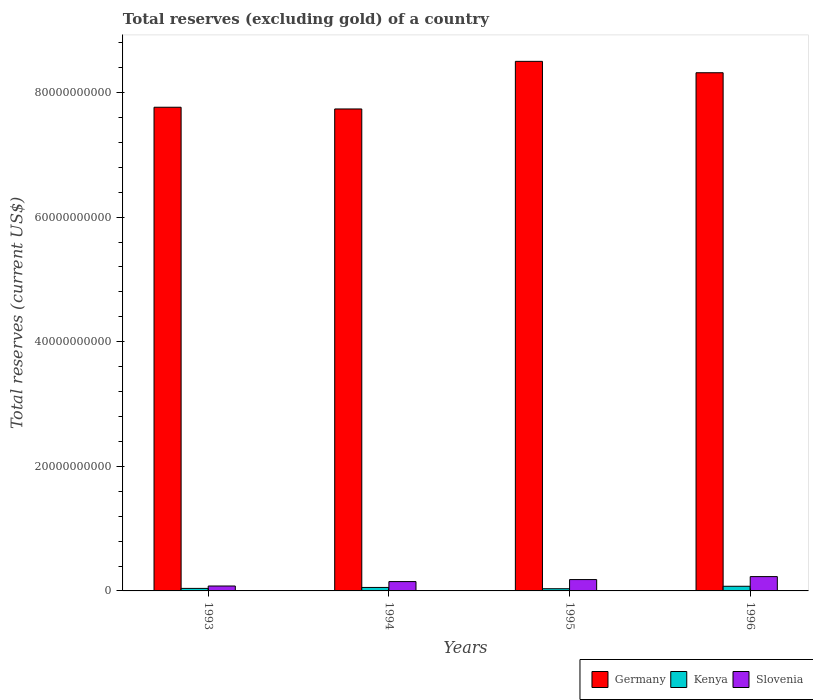How many groups of bars are there?
Your response must be concise. 4. Are the number of bars on each tick of the X-axis equal?
Offer a terse response. Yes. In how many cases, is the number of bars for a given year not equal to the number of legend labels?
Your response must be concise. 0. What is the total reserves (excluding gold) in Germany in 1995?
Provide a succinct answer. 8.50e+1. Across all years, what is the maximum total reserves (excluding gold) in Slovenia?
Your response must be concise. 2.30e+09. Across all years, what is the minimum total reserves (excluding gold) in Slovenia?
Your answer should be compact. 7.88e+08. What is the total total reserves (excluding gold) in Kenya in the graph?
Make the answer very short. 2.06e+09. What is the difference between the total reserves (excluding gold) in Kenya in 1994 and that in 1995?
Your response must be concise. 2.04e+08. What is the difference between the total reserves (excluding gold) in Kenya in 1993 and the total reserves (excluding gold) in Slovenia in 1995?
Provide a succinct answer. -1.42e+09. What is the average total reserves (excluding gold) in Germany per year?
Ensure brevity in your answer.  8.08e+1. In the year 1994, what is the difference between the total reserves (excluding gold) in Kenya and total reserves (excluding gold) in Germany?
Your answer should be very brief. -7.68e+1. In how many years, is the total reserves (excluding gold) in Kenya greater than 64000000000 US$?
Your answer should be compact. 0. What is the ratio of the total reserves (excluding gold) in Slovenia in 1993 to that in 1995?
Provide a short and direct response. 0.43. What is the difference between the highest and the second highest total reserves (excluding gold) in Germany?
Make the answer very short. 1.83e+09. What is the difference between the highest and the lowest total reserves (excluding gold) in Kenya?
Ensure brevity in your answer.  3.93e+08. In how many years, is the total reserves (excluding gold) in Kenya greater than the average total reserves (excluding gold) in Kenya taken over all years?
Your response must be concise. 2. Is the sum of the total reserves (excluding gold) in Slovenia in 1993 and 1994 greater than the maximum total reserves (excluding gold) in Kenya across all years?
Provide a short and direct response. Yes. What does the 1st bar from the left in 1994 represents?
Keep it short and to the point. Germany. Does the graph contain any zero values?
Offer a terse response. No. Does the graph contain grids?
Your answer should be very brief. No. What is the title of the graph?
Give a very brief answer. Total reserves (excluding gold) of a country. Does "Cyprus" appear as one of the legend labels in the graph?
Ensure brevity in your answer.  No. What is the label or title of the X-axis?
Make the answer very short. Years. What is the label or title of the Y-axis?
Your response must be concise. Total reserves (current US$). What is the Total reserves (current US$) in Germany in 1993?
Ensure brevity in your answer.  7.76e+1. What is the Total reserves (current US$) in Kenya in 1993?
Give a very brief answer. 4.06e+08. What is the Total reserves (current US$) of Slovenia in 1993?
Offer a very short reply. 7.88e+08. What is the Total reserves (current US$) of Germany in 1994?
Your answer should be compact. 7.74e+1. What is the Total reserves (current US$) of Kenya in 1994?
Give a very brief answer. 5.58e+08. What is the Total reserves (current US$) in Slovenia in 1994?
Keep it short and to the point. 1.50e+09. What is the Total reserves (current US$) in Germany in 1995?
Your answer should be compact. 8.50e+1. What is the Total reserves (current US$) of Kenya in 1995?
Make the answer very short. 3.53e+08. What is the Total reserves (current US$) of Slovenia in 1995?
Make the answer very short. 1.82e+09. What is the Total reserves (current US$) of Germany in 1996?
Keep it short and to the point. 8.32e+1. What is the Total reserves (current US$) in Kenya in 1996?
Your response must be concise. 7.46e+08. What is the Total reserves (current US$) of Slovenia in 1996?
Give a very brief answer. 2.30e+09. Across all years, what is the maximum Total reserves (current US$) in Germany?
Give a very brief answer. 8.50e+1. Across all years, what is the maximum Total reserves (current US$) of Kenya?
Your answer should be very brief. 7.46e+08. Across all years, what is the maximum Total reserves (current US$) of Slovenia?
Your answer should be very brief. 2.30e+09. Across all years, what is the minimum Total reserves (current US$) in Germany?
Your response must be concise. 7.74e+1. Across all years, what is the minimum Total reserves (current US$) in Kenya?
Give a very brief answer. 3.53e+08. Across all years, what is the minimum Total reserves (current US$) in Slovenia?
Your answer should be compact. 7.88e+08. What is the total Total reserves (current US$) of Germany in the graph?
Your answer should be very brief. 3.23e+11. What is the total Total reserves (current US$) of Kenya in the graph?
Your answer should be compact. 2.06e+09. What is the total Total reserves (current US$) of Slovenia in the graph?
Ensure brevity in your answer.  6.40e+09. What is the difference between the Total reserves (current US$) in Germany in 1993 and that in 1994?
Your answer should be very brief. 2.77e+08. What is the difference between the Total reserves (current US$) of Kenya in 1993 and that in 1994?
Provide a short and direct response. -1.52e+08. What is the difference between the Total reserves (current US$) in Slovenia in 1993 and that in 1994?
Make the answer very short. -7.11e+08. What is the difference between the Total reserves (current US$) in Germany in 1993 and that in 1995?
Ensure brevity in your answer.  -7.37e+09. What is the difference between the Total reserves (current US$) of Kenya in 1993 and that in 1995?
Make the answer very short. 5.22e+07. What is the difference between the Total reserves (current US$) in Slovenia in 1993 and that in 1995?
Your response must be concise. -1.03e+09. What is the difference between the Total reserves (current US$) of Germany in 1993 and that in 1996?
Offer a very short reply. -5.54e+09. What is the difference between the Total reserves (current US$) of Kenya in 1993 and that in 1996?
Offer a terse response. -3.41e+08. What is the difference between the Total reserves (current US$) of Slovenia in 1993 and that in 1996?
Offer a very short reply. -1.51e+09. What is the difference between the Total reserves (current US$) in Germany in 1994 and that in 1995?
Make the answer very short. -7.64e+09. What is the difference between the Total reserves (current US$) in Kenya in 1994 and that in 1995?
Your response must be concise. 2.04e+08. What is the difference between the Total reserves (current US$) in Slovenia in 1994 and that in 1995?
Your answer should be compact. -3.22e+08. What is the difference between the Total reserves (current US$) of Germany in 1994 and that in 1996?
Ensure brevity in your answer.  -5.81e+09. What is the difference between the Total reserves (current US$) in Kenya in 1994 and that in 1996?
Your answer should be compact. -1.89e+08. What is the difference between the Total reserves (current US$) in Slovenia in 1994 and that in 1996?
Give a very brief answer. -7.98e+08. What is the difference between the Total reserves (current US$) of Germany in 1995 and that in 1996?
Offer a terse response. 1.83e+09. What is the difference between the Total reserves (current US$) of Kenya in 1995 and that in 1996?
Make the answer very short. -3.93e+08. What is the difference between the Total reserves (current US$) in Slovenia in 1995 and that in 1996?
Your answer should be compact. -4.77e+08. What is the difference between the Total reserves (current US$) of Germany in 1993 and the Total reserves (current US$) of Kenya in 1994?
Give a very brief answer. 7.71e+1. What is the difference between the Total reserves (current US$) in Germany in 1993 and the Total reserves (current US$) in Slovenia in 1994?
Your response must be concise. 7.61e+1. What is the difference between the Total reserves (current US$) in Kenya in 1993 and the Total reserves (current US$) in Slovenia in 1994?
Your answer should be compact. -1.09e+09. What is the difference between the Total reserves (current US$) of Germany in 1993 and the Total reserves (current US$) of Kenya in 1995?
Your response must be concise. 7.73e+1. What is the difference between the Total reserves (current US$) of Germany in 1993 and the Total reserves (current US$) of Slovenia in 1995?
Ensure brevity in your answer.  7.58e+1. What is the difference between the Total reserves (current US$) of Kenya in 1993 and the Total reserves (current US$) of Slovenia in 1995?
Provide a succinct answer. -1.42e+09. What is the difference between the Total reserves (current US$) of Germany in 1993 and the Total reserves (current US$) of Kenya in 1996?
Offer a very short reply. 7.69e+1. What is the difference between the Total reserves (current US$) in Germany in 1993 and the Total reserves (current US$) in Slovenia in 1996?
Keep it short and to the point. 7.53e+1. What is the difference between the Total reserves (current US$) of Kenya in 1993 and the Total reserves (current US$) of Slovenia in 1996?
Your response must be concise. -1.89e+09. What is the difference between the Total reserves (current US$) of Germany in 1994 and the Total reserves (current US$) of Kenya in 1995?
Your response must be concise. 7.70e+1. What is the difference between the Total reserves (current US$) of Germany in 1994 and the Total reserves (current US$) of Slovenia in 1995?
Offer a terse response. 7.55e+1. What is the difference between the Total reserves (current US$) of Kenya in 1994 and the Total reserves (current US$) of Slovenia in 1995?
Give a very brief answer. -1.26e+09. What is the difference between the Total reserves (current US$) in Germany in 1994 and the Total reserves (current US$) in Kenya in 1996?
Ensure brevity in your answer.  7.66e+1. What is the difference between the Total reserves (current US$) in Germany in 1994 and the Total reserves (current US$) in Slovenia in 1996?
Give a very brief answer. 7.51e+1. What is the difference between the Total reserves (current US$) in Kenya in 1994 and the Total reserves (current US$) in Slovenia in 1996?
Your answer should be very brief. -1.74e+09. What is the difference between the Total reserves (current US$) of Germany in 1995 and the Total reserves (current US$) of Kenya in 1996?
Keep it short and to the point. 8.43e+1. What is the difference between the Total reserves (current US$) in Germany in 1995 and the Total reserves (current US$) in Slovenia in 1996?
Offer a very short reply. 8.27e+1. What is the difference between the Total reserves (current US$) in Kenya in 1995 and the Total reserves (current US$) in Slovenia in 1996?
Provide a succinct answer. -1.94e+09. What is the average Total reserves (current US$) of Germany per year?
Your response must be concise. 8.08e+1. What is the average Total reserves (current US$) in Kenya per year?
Your answer should be compact. 5.16e+08. What is the average Total reserves (current US$) of Slovenia per year?
Your answer should be compact. 1.60e+09. In the year 1993, what is the difference between the Total reserves (current US$) in Germany and Total reserves (current US$) in Kenya?
Provide a short and direct response. 7.72e+1. In the year 1993, what is the difference between the Total reserves (current US$) of Germany and Total reserves (current US$) of Slovenia?
Your answer should be compact. 7.69e+1. In the year 1993, what is the difference between the Total reserves (current US$) in Kenya and Total reserves (current US$) in Slovenia?
Your response must be concise. -3.82e+08. In the year 1994, what is the difference between the Total reserves (current US$) in Germany and Total reserves (current US$) in Kenya?
Your answer should be compact. 7.68e+1. In the year 1994, what is the difference between the Total reserves (current US$) of Germany and Total reserves (current US$) of Slovenia?
Keep it short and to the point. 7.59e+1. In the year 1994, what is the difference between the Total reserves (current US$) in Kenya and Total reserves (current US$) in Slovenia?
Provide a succinct answer. -9.41e+08. In the year 1995, what is the difference between the Total reserves (current US$) in Germany and Total reserves (current US$) in Kenya?
Ensure brevity in your answer.  8.47e+1. In the year 1995, what is the difference between the Total reserves (current US$) of Germany and Total reserves (current US$) of Slovenia?
Offer a very short reply. 8.32e+1. In the year 1995, what is the difference between the Total reserves (current US$) of Kenya and Total reserves (current US$) of Slovenia?
Your answer should be compact. -1.47e+09. In the year 1996, what is the difference between the Total reserves (current US$) in Germany and Total reserves (current US$) in Kenya?
Give a very brief answer. 8.24e+1. In the year 1996, what is the difference between the Total reserves (current US$) of Germany and Total reserves (current US$) of Slovenia?
Your answer should be compact. 8.09e+1. In the year 1996, what is the difference between the Total reserves (current US$) in Kenya and Total reserves (current US$) in Slovenia?
Your answer should be very brief. -1.55e+09. What is the ratio of the Total reserves (current US$) of Germany in 1993 to that in 1994?
Provide a succinct answer. 1. What is the ratio of the Total reserves (current US$) of Kenya in 1993 to that in 1994?
Offer a terse response. 0.73. What is the ratio of the Total reserves (current US$) in Slovenia in 1993 to that in 1994?
Your response must be concise. 0.53. What is the ratio of the Total reserves (current US$) of Germany in 1993 to that in 1995?
Make the answer very short. 0.91. What is the ratio of the Total reserves (current US$) of Kenya in 1993 to that in 1995?
Your answer should be very brief. 1.15. What is the ratio of the Total reserves (current US$) of Slovenia in 1993 to that in 1995?
Your answer should be compact. 0.43. What is the ratio of the Total reserves (current US$) of Germany in 1993 to that in 1996?
Provide a succinct answer. 0.93. What is the ratio of the Total reserves (current US$) in Kenya in 1993 to that in 1996?
Make the answer very short. 0.54. What is the ratio of the Total reserves (current US$) of Slovenia in 1993 to that in 1996?
Provide a short and direct response. 0.34. What is the ratio of the Total reserves (current US$) in Germany in 1994 to that in 1995?
Offer a terse response. 0.91. What is the ratio of the Total reserves (current US$) of Kenya in 1994 to that in 1995?
Ensure brevity in your answer.  1.58. What is the ratio of the Total reserves (current US$) of Slovenia in 1994 to that in 1995?
Keep it short and to the point. 0.82. What is the ratio of the Total reserves (current US$) of Germany in 1994 to that in 1996?
Offer a very short reply. 0.93. What is the ratio of the Total reserves (current US$) of Kenya in 1994 to that in 1996?
Keep it short and to the point. 0.75. What is the ratio of the Total reserves (current US$) of Slovenia in 1994 to that in 1996?
Your answer should be very brief. 0.65. What is the ratio of the Total reserves (current US$) of Germany in 1995 to that in 1996?
Provide a short and direct response. 1.02. What is the ratio of the Total reserves (current US$) in Kenya in 1995 to that in 1996?
Ensure brevity in your answer.  0.47. What is the ratio of the Total reserves (current US$) in Slovenia in 1995 to that in 1996?
Your response must be concise. 0.79. What is the difference between the highest and the second highest Total reserves (current US$) of Germany?
Your answer should be very brief. 1.83e+09. What is the difference between the highest and the second highest Total reserves (current US$) of Kenya?
Your answer should be compact. 1.89e+08. What is the difference between the highest and the second highest Total reserves (current US$) in Slovenia?
Offer a very short reply. 4.77e+08. What is the difference between the highest and the lowest Total reserves (current US$) of Germany?
Provide a succinct answer. 7.64e+09. What is the difference between the highest and the lowest Total reserves (current US$) of Kenya?
Your answer should be very brief. 3.93e+08. What is the difference between the highest and the lowest Total reserves (current US$) in Slovenia?
Offer a terse response. 1.51e+09. 